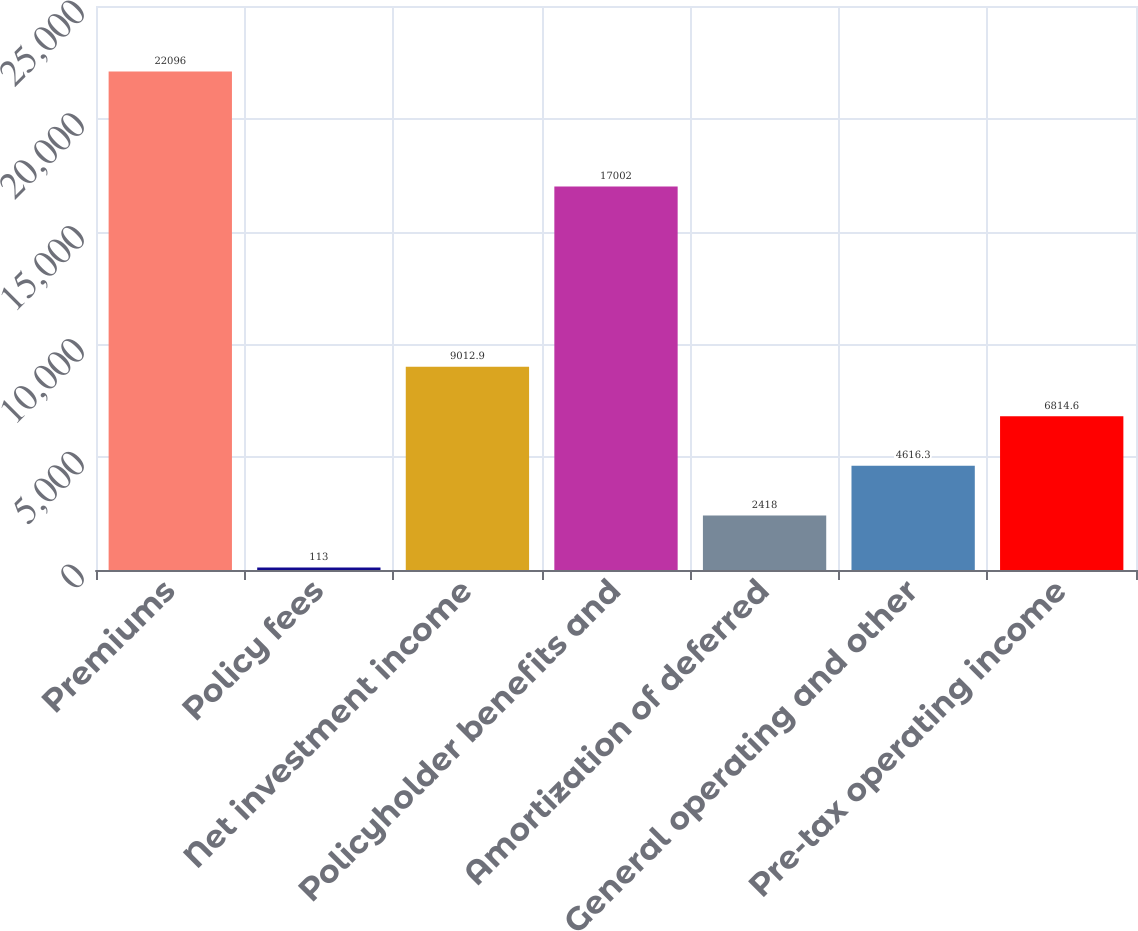Convert chart. <chart><loc_0><loc_0><loc_500><loc_500><bar_chart><fcel>Premiums<fcel>Policy fees<fcel>Net investment income<fcel>Policyholder benefits and<fcel>Amortization of deferred<fcel>General operating and other<fcel>Pre-tax operating income<nl><fcel>22096<fcel>113<fcel>9012.9<fcel>17002<fcel>2418<fcel>4616.3<fcel>6814.6<nl></chart> 